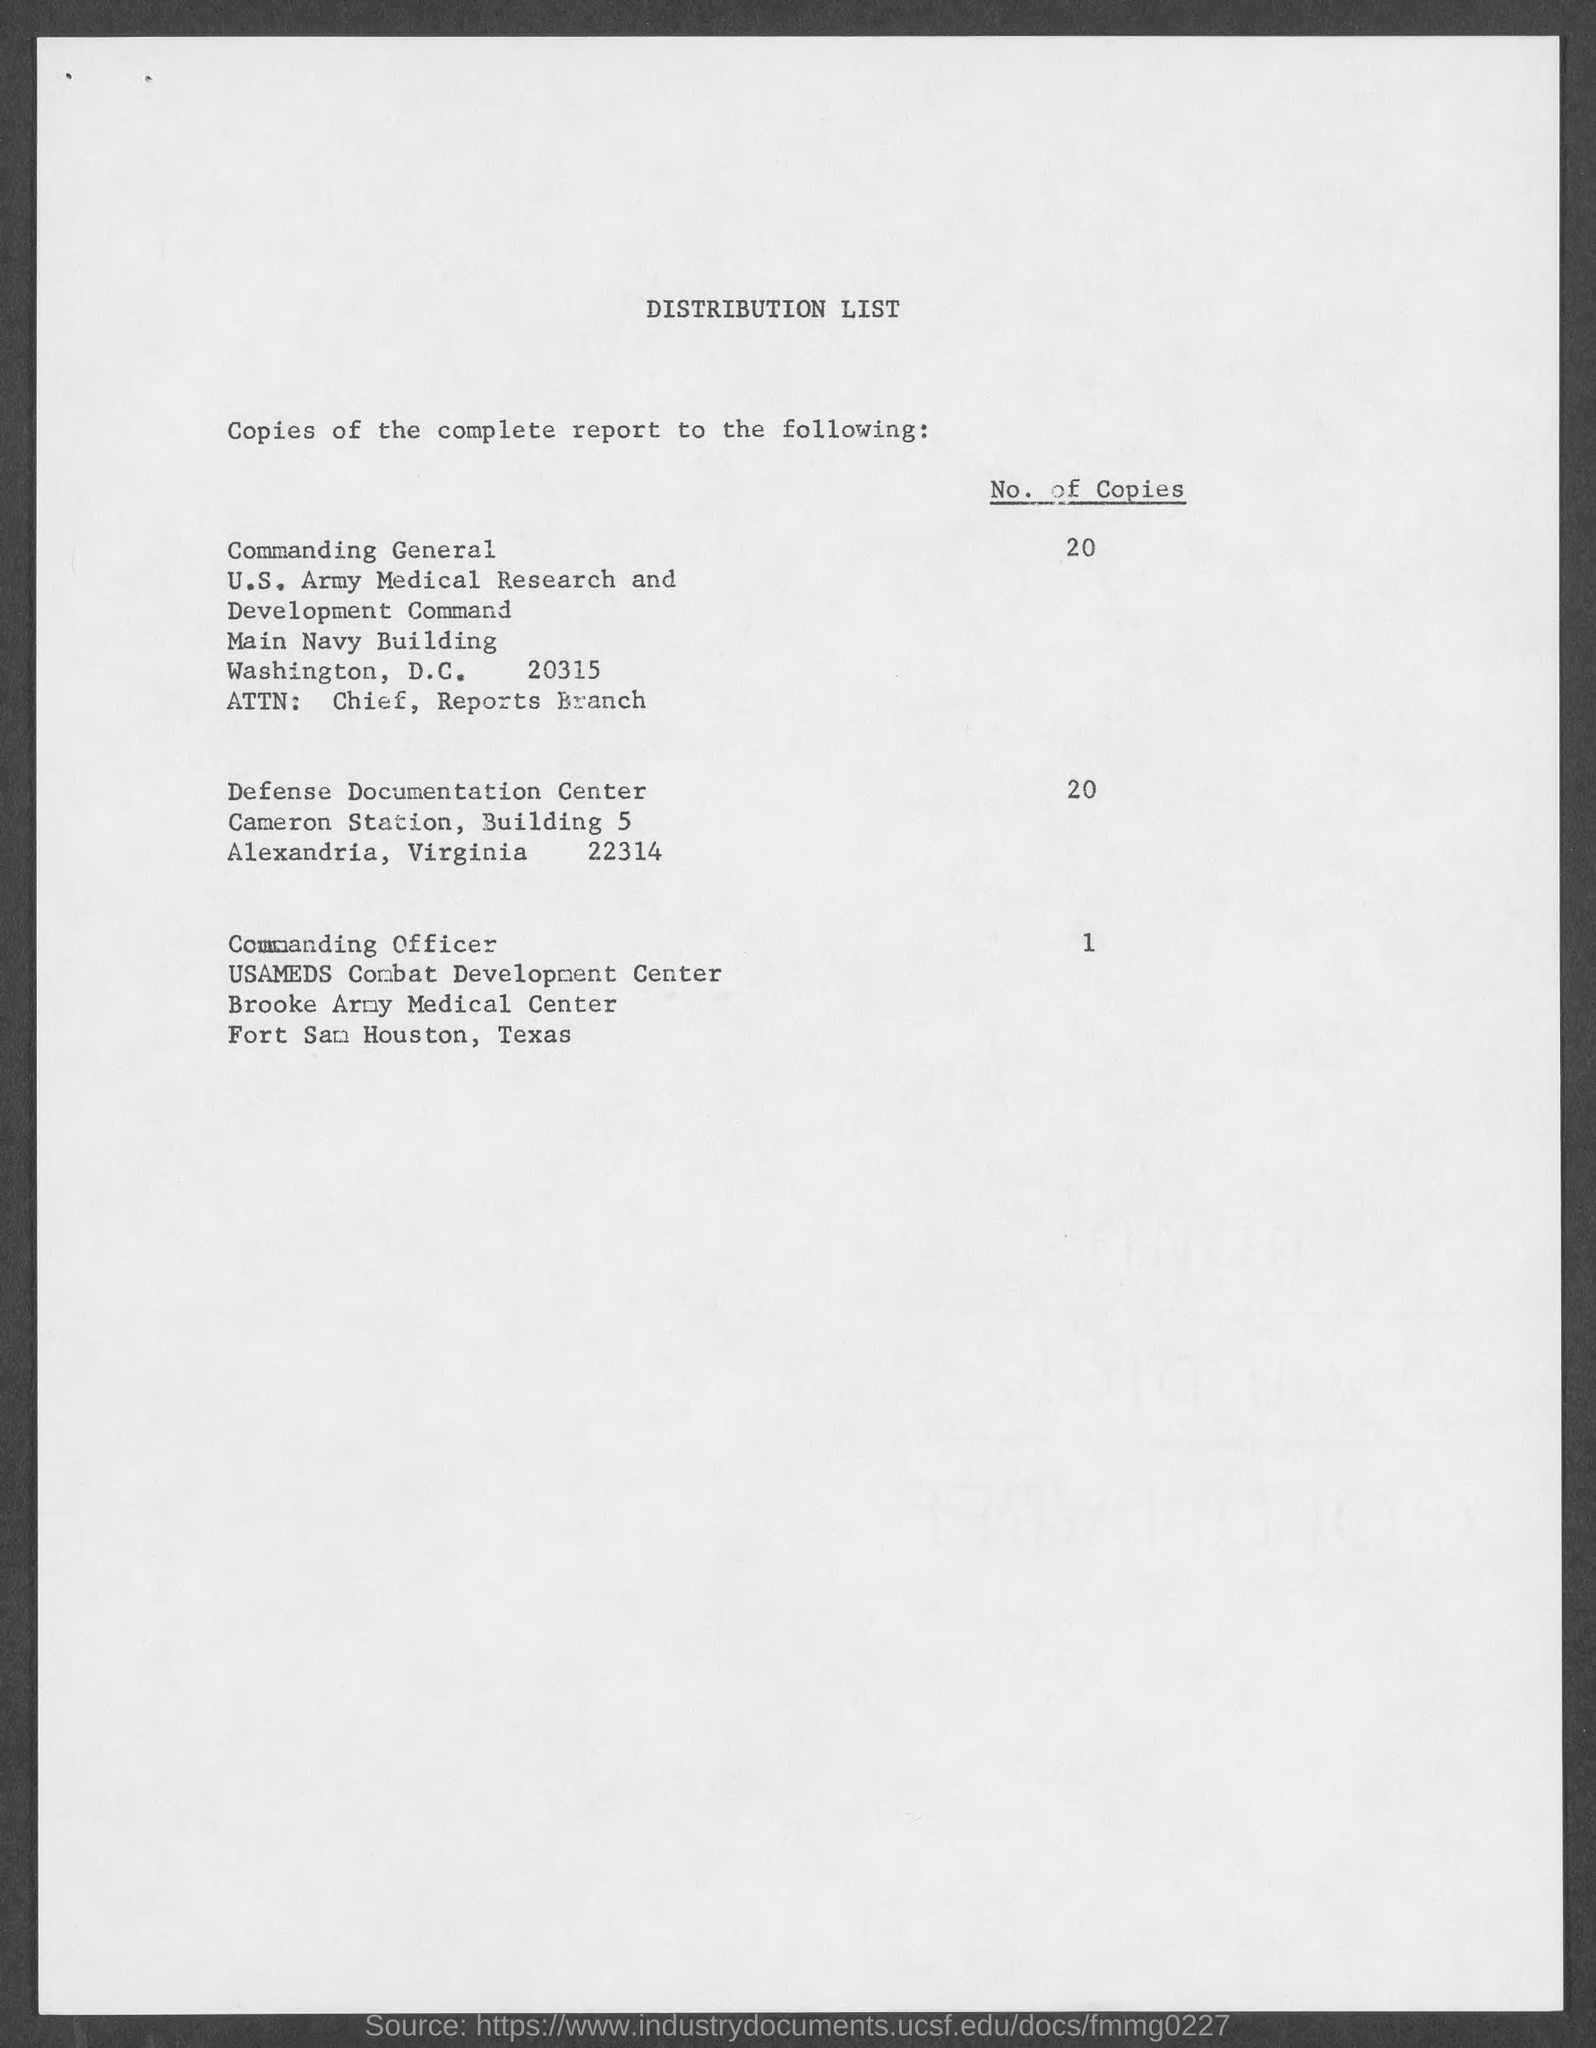Could you tell me what organizations are listed as recipients on this distribution list?  The organizations listed as recipients include the U.S. Army Medical Research and Development Command in Washington, D.C., the Defense Documentation Center in Alexandria, Virginia, and the Brooke Army Medical Center in Fort Sam Houston, Texas. 